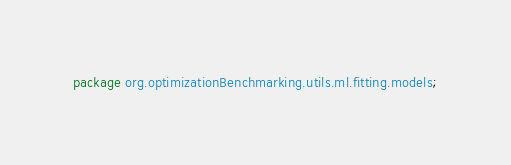Convert code to text. <code><loc_0><loc_0><loc_500><loc_500><_Java_>package org.optimizationBenchmarking.utils.ml.fitting.models;</code> 